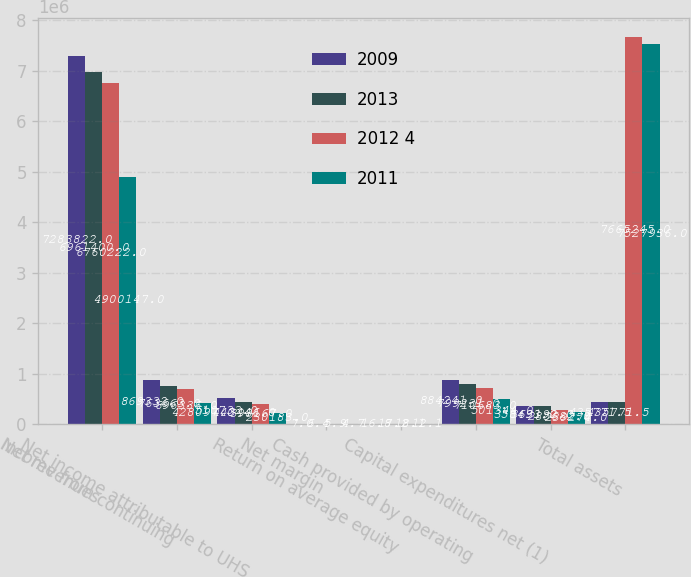Convert chart. <chart><loc_0><loc_0><loc_500><loc_500><stacked_bar_chart><ecel><fcel>Net revenues<fcel>Income from continuing<fcel>Net income attributable to UHS<fcel>Net margin<fcel>Return on average equity<fcel>Cash provided by operating<fcel>Capital expenditures net (1)<fcel>Total assets<nl><fcel>2009<fcel>7.28382e+06<fcel>869332<fcel>510733<fcel>7<fcel>16.8<fcel>884241<fcel>358493<fcel>435772<nl><fcel>2013<fcel>6.9614e+06<fcel>763663<fcel>443446<fcel>6.4<fcel>17.2<fcel>799231<fcel>363192<fcel>435772<nl><fcel>2012 4<fcel>6.76022e+06<fcel>696336<fcel>398167<fcel>5.9<fcel>18.1<fcel>710683<fcel>285682<fcel>7.66524e+06<nl><fcel>2011<fcel>4.90015e+06<fcel>428097<fcel>230183<fcel>4.7<fcel>12.1<fcel>501344<fcel>239274<fcel>7.52794e+06<nl></chart> 